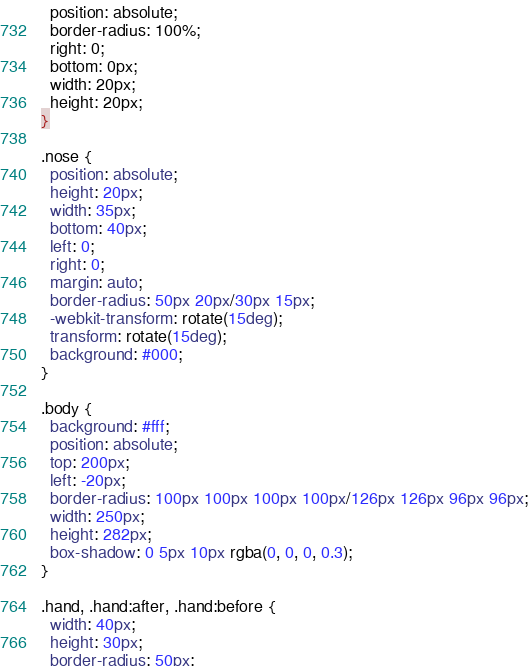Convert code to text. <code><loc_0><loc_0><loc_500><loc_500><_CSS_>  position: absolute;
  border-radius: 100%;
  right: 0;
  bottom: 0px;
  width: 20px;
  height: 20px;
}

.nose {
  position: absolute;
  height: 20px;
  width: 35px;
  bottom: 40px;
  left: 0;
  right: 0;
  margin: auto;
  border-radius: 50px 20px/30px 15px;
  -webkit-transform: rotate(15deg);
  transform: rotate(15deg);
  background: #000;
}

.body {
  background: #fff;
  position: absolute;
  top: 200px;
  left: -20px;
  border-radius: 100px 100px 100px 100px/126px 126px 96px 96px;
  width: 250px;
  height: 282px;
  box-shadow: 0 5px 10px rgba(0, 0, 0, 0.3);
}

.hand, .hand:after, .hand:before {
  width: 40px;
  height: 30px;
  border-radius: 50px;</code> 